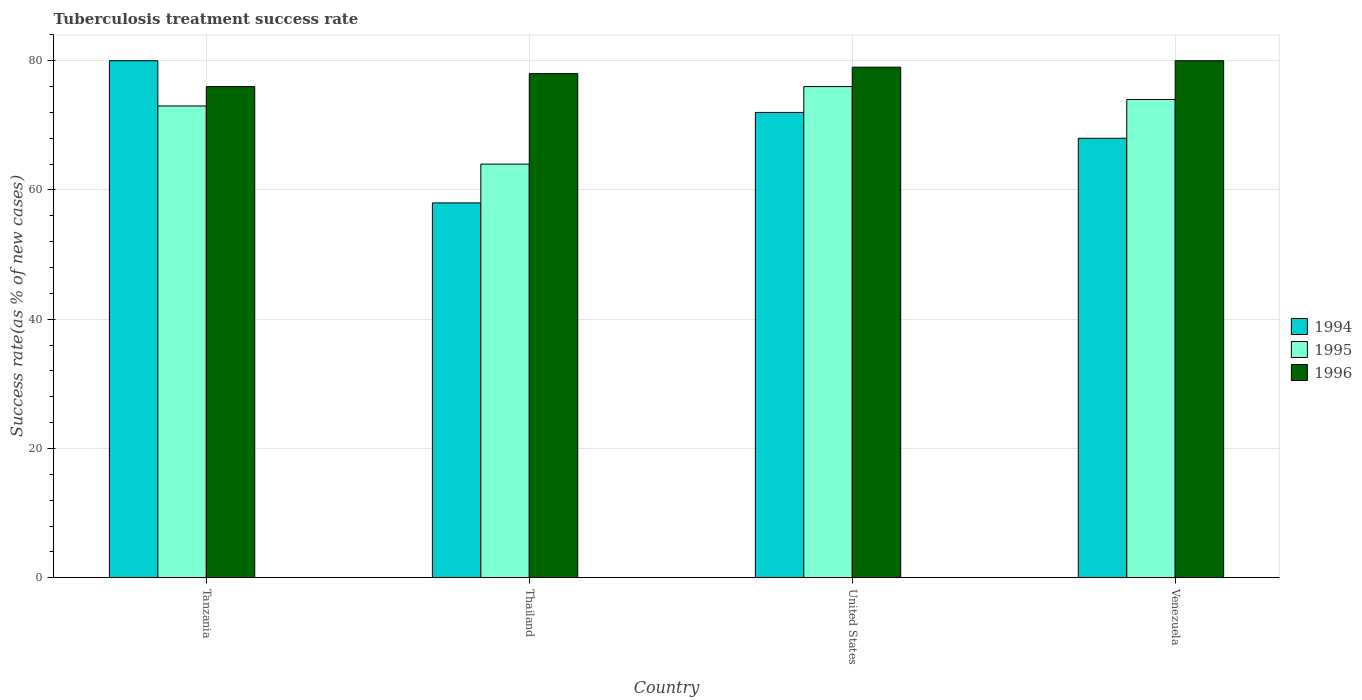How many different coloured bars are there?
Offer a terse response. 3. How many groups of bars are there?
Provide a short and direct response. 4. Are the number of bars per tick equal to the number of legend labels?
Your answer should be very brief. Yes. Are the number of bars on each tick of the X-axis equal?
Give a very brief answer. Yes. What is the label of the 1st group of bars from the left?
Your answer should be compact. Tanzania. In how many cases, is the number of bars for a given country not equal to the number of legend labels?
Provide a succinct answer. 0. What is the tuberculosis treatment success rate in 1996 in Venezuela?
Provide a succinct answer. 80. In which country was the tuberculosis treatment success rate in 1996 maximum?
Offer a terse response. Venezuela. In which country was the tuberculosis treatment success rate in 1995 minimum?
Your answer should be very brief. Thailand. What is the total tuberculosis treatment success rate in 1996 in the graph?
Offer a terse response. 313. What is the average tuberculosis treatment success rate in 1994 per country?
Your response must be concise. 69.5. In how many countries, is the tuberculosis treatment success rate in 1994 greater than 60 %?
Ensure brevity in your answer.  3. What is the ratio of the tuberculosis treatment success rate in 1995 in Thailand to that in United States?
Make the answer very short. 0.84. Is the tuberculosis treatment success rate in 1996 in United States less than that in Venezuela?
Offer a terse response. Yes. What is the difference between the highest and the second highest tuberculosis treatment success rate in 1995?
Give a very brief answer. -1. What does the 2nd bar from the right in United States represents?
Your response must be concise. 1995. Are all the bars in the graph horizontal?
Make the answer very short. No. What is the difference between two consecutive major ticks on the Y-axis?
Offer a terse response. 20. Are the values on the major ticks of Y-axis written in scientific E-notation?
Offer a terse response. No. Does the graph contain any zero values?
Keep it short and to the point. No. Where does the legend appear in the graph?
Offer a terse response. Center right. How many legend labels are there?
Offer a very short reply. 3. How are the legend labels stacked?
Provide a succinct answer. Vertical. What is the title of the graph?
Your answer should be very brief. Tuberculosis treatment success rate. Does "1965" appear as one of the legend labels in the graph?
Your response must be concise. No. What is the label or title of the X-axis?
Your response must be concise. Country. What is the label or title of the Y-axis?
Ensure brevity in your answer.  Success rate(as % of new cases). What is the Success rate(as % of new cases) of 1996 in Tanzania?
Offer a very short reply. 76. What is the Success rate(as % of new cases) of 1994 in Thailand?
Give a very brief answer. 58. What is the Success rate(as % of new cases) of 1995 in Thailand?
Ensure brevity in your answer.  64. What is the Success rate(as % of new cases) of 1996 in Thailand?
Offer a terse response. 78. What is the Success rate(as % of new cases) of 1996 in United States?
Provide a short and direct response. 79. Across all countries, what is the maximum Success rate(as % of new cases) in 1996?
Keep it short and to the point. 80. Across all countries, what is the minimum Success rate(as % of new cases) of 1995?
Offer a terse response. 64. Across all countries, what is the minimum Success rate(as % of new cases) in 1996?
Offer a very short reply. 76. What is the total Success rate(as % of new cases) in 1994 in the graph?
Your response must be concise. 278. What is the total Success rate(as % of new cases) in 1995 in the graph?
Offer a terse response. 287. What is the total Success rate(as % of new cases) in 1996 in the graph?
Offer a very short reply. 313. What is the difference between the Success rate(as % of new cases) in 1994 in Tanzania and that in Thailand?
Your answer should be very brief. 22. What is the difference between the Success rate(as % of new cases) of 1995 in Tanzania and that in Thailand?
Provide a short and direct response. 9. What is the difference between the Success rate(as % of new cases) of 1996 in Tanzania and that in Thailand?
Keep it short and to the point. -2. What is the difference between the Success rate(as % of new cases) of 1994 in Tanzania and that in United States?
Provide a succinct answer. 8. What is the difference between the Success rate(as % of new cases) in 1996 in Tanzania and that in Venezuela?
Keep it short and to the point. -4. What is the difference between the Success rate(as % of new cases) of 1994 in Thailand and that in United States?
Your response must be concise. -14. What is the difference between the Success rate(as % of new cases) in 1996 in Thailand and that in United States?
Your answer should be compact. -1. What is the difference between the Success rate(as % of new cases) in 1994 in Thailand and that in Venezuela?
Ensure brevity in your answer.  -10. What is the difference between the Success rate(as % of new cases) in 1996 in Thailand and that in Venezuela?
Your response must be concise. -2. What is the difference between the Success rate(as % of new cases) of 1995 in United States and that in Venezuela?
Your response must be concise. 2. What is the difference between the Success rate(as % of new cases) of 1994 in Tanzania and the Success rate(as % of new cases) of 1996 in Thailand?
Offer a very short reply. 2. What is the difference between the Success rate(as % of new cases) in 1994 in Tanzania and the Success rate(as % of new cases) in 1995 in United States?
Offer a very short reply. 4. What is the difference between the Success rate(as % of new cases) in 1994 in Tanzania and the Success rate(as % of new cases) in 1996 in United States?
Ensure brevity in your answer.  1. What is the difference between the Success rate(as % of new cases) in 1994 in Thailand and the Success rate(as % of new cases) in 1995 in Venezuela?
Your answer should be compact. -16. What is the difference between the Success rate(as % of new cases) in 1994 in Thailand and the Success rate(as % of new cases) in 1996 in Venezuela?
Offer a terse response. -22. What is the difference between the Success rate(as % of new cases) of 1995 in Thailand and the Success rate(as % of new cases) of 1996 in Venezuela?
Provide a short and direct response. -16. What is the difference between the Success rate(as % of new cases) of 1994 in United States and the Success rate(as % of new cases) of 1996 in Venezuela?
Your response must be concise. -8. What is the average Success rate(as % of new cases) in 1994 per country?
Ensure brevity in your answer.  69.5. What is the average Success rate(as % of new cases) in 1995 per country?
Your answer should be compact. 71.75. What is the average Success rate(as % of new cases) in 1996 per country?
Offer a terse response. 78.25. What is the difference between the Success rate(as % of new cases) in 1995 and Success rate(as % of new cases) in 1996 in Tanzania?
Make the answer very short. -3. What is the difference between the Success rate(as % of new cases) in 1994 and Success rate(as % of new cases) in 1995 in Thailand?
Offer a terse response. -6. What is the difference between the Success rate(as % of new cases) in 1994 and Success rate(as % of new cases) in 1996 in Thailand?
Give a very brief answer. -20. What is the difference between the Success rate(as % of new cases) in 1995 and Success rate(as % of new cases) in 1996 in Thailand?
Your answer should be compact. -14. What is the difference between the Success rate(as % of new cases) in 1994 and Success rate(as % of new cases) in 1995 in United States?
Offer a terse response. -4. What is the ratio of the Success rate(as % of new cases) of 1994 in Tanzania to that in Thailand?
Your answer should be very brief. 1.38. What is the ratio of the Success rate(as % of new cases) in 1995 in Tanzania to that in Thailand?
Your answer should be very brief. 1.14. What is the ratio of the Success rate(as % of new cases) in 1996 in Tanzania to that in Thailand?
Offer a terse response. 0.97. What is the ratio of the Success rate(as % of new cases) of 1994 in Tanzania to that in United States?
Your response must be concise. 1.11. What is the ratio of the Success rate(as % of new cases) in 1995 in Tanzania to that in United States?
Ensure brevity in your answer.  0.96. What is the ratio of the Success rate(as % of new cases) in 1994 in Tanzania to that in Venezuela?
Provide a succinct answer. 1.18. What is the ratio of the Success rate(as % of new cases) of 1995 in Tanzania to that in Venezuela?
Provide a short and direct response. 0.99. What is the ratio of the Success rate(as % of new cases) of 1996 in Tanzania to that in Venezuela?
Your answer should be compact. 0.95. What is the ratio of the Success rate(as % of new cases) of 1994 in Thailand to that in United States?
Offer a terse response. 0.81. What is the ratio of the Success rate(as % of new cases) in 1995 in Thailand to that in United States?
Offer a terse response. 0.84. What is the ratio of the Success rate(as % of new cases) in 1996 in Thailand to that in United States?
Ensure brevity in your answer.  0.99. What is the ratio of the Success rate(as % of new cases) in 1994 in Thailand to that in Venezuela?
Offer a terse response. 0.85. What is the ratio of the Success rate(as % of new cases) in 1995 in Thailand to that in Venezuela?
Provide a short and direct response. 0.86. What is the ratio of the Success rate(as % of new cases) of 1994 in United States to that in Venezuela?
Your answer should be very brief. 1.06. What is the ratio of the Success rate(as % of new cases) in 1995 in United States to that in Venezuela?
Your response must be concise. 1.03. What is the ratio of the Success rate(as % of new cases) of 1996 in United States to that in Venezuela?
Ensure brevity in your answer.  0.99. What is the difference between the highest and the second highest Success rate(as % of new cases) of 1994?
Give a very brief answer. 8. What is the difference between the highest and the lowest Success rate(as % of new cases) in 1994?
Provide a succinct answer. 22. 